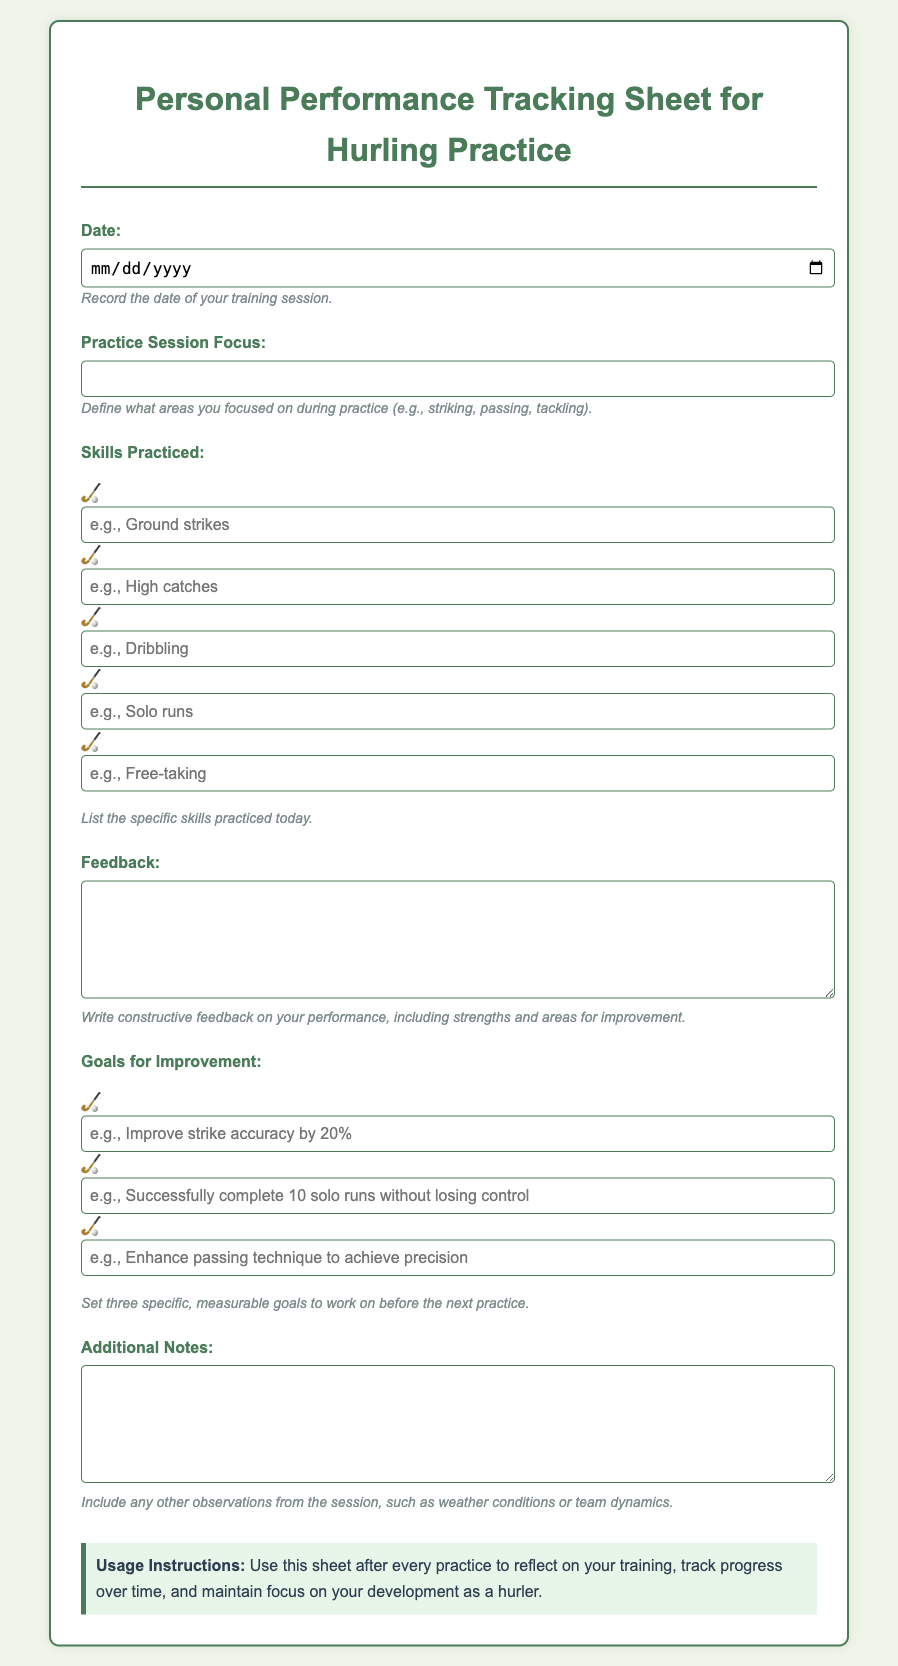What is the title of the document? The title is presented prominently at the top of the document, identifying the content it covers.
Answer: Personal Performance Tracking Sheet for Hurling Practice What should be recorded in the "Date" field? This field specifies when the hurling practice session took place.
Answer: The date of your training session What types of skills can be practiced according to the document? Specific examples of skills are provided to give clarity on what can be recorded.
Answer: Ground strikes, High catches, Dribbling, Solo runs, Free-taking How many goals for improvement should be set? The document specifies a quantity for measurable goals to focus on for improvement.
Answer: Three What is the color of the background for the document? The background color is described directly in the style section of the document.
Answer: Light green What type of feedback is encouraged in the document? The document provides guidance on the type of feedback to record after practice.
Answer: Constructive feedback on your performance What is the purpose of the "Additional Notes" section? This section allows for further reflections beyond the primary areas of focus in practice.
Answer: Observations from the session What kind of list does the "Skills Practiced" section contain? The document outlines the format and nature of the entries expected in this section.
Answer: A checklist of specific skills practiced What does the "Usage Instructions" section advise? This section gives guidance on how to utilize the document effectively over time.
Answer: Reflect on your training, track progress, and maintain focus on development 